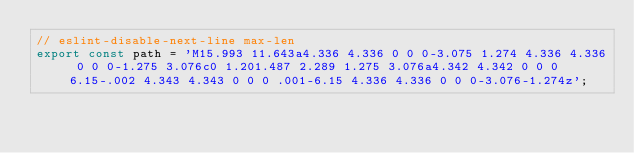Convert code to text. <code><loc_0><loc_0><loc_500><loc_500><_TypeScript_>// eslint-disable-next-line max-len
export const path = 'M15.993 11.643a4.336 4.336 0 0 0-3.075 1.274 4.336 4.336 0 0 0-1.275 3.076c0 1.201.487 2.289 1.275 3.076a4.342 4.342 0 0 0 6.15-.002 4.343 4.343 0 0 0 .001-6.15 4.336 4.336 0 0 0-3.076-1.274z';
</code> 